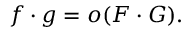Convert formula to latex. <formula><loc_0><loc_0><loc_500><loc_500>f \cdot g = o ( F \cdot G ) .</formula> 